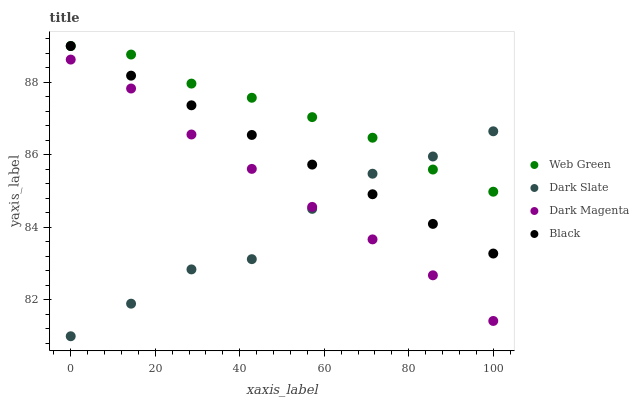Does Dark Slate have the minimum area under the curve?
Answer yes or no. Yes. Does Web Green have the maximum area under the curve?
Answer yes or no. Yes. Does Black have the minimum area under the curve?
Answer yes or no. No. Does Black have the maximum area under the curve?
Answer yes or no. No. Is Black the smoothest?
Answer yes or no. Yes. Is Dark Slate the roughest?
Answer yes or no. Yes. Is Dark Magenta the smoothest?
Answer yes or no. No. Is Dark Magenta the roughest?
Answer yes or no. No. Does Dark Slate have the lowest value?
Answer yes or no. Yes. Does Black have the lowest value?
Answer yes or no. No. Does Web Green have the highest value?
Answer yes or no. Yes. Does Dark Magenta have the highest value?
Answer yes or no. No. Is Dark Magenta less than Web Green?
Answer yes or no. Yes. Is Black greater than Dark Magenta?
Answer yes or no. Yes. Does Dark Slate intersect Web Green?
Answer yes or no. Yes. Is Dark Slate less than Web Green?
Answer yes or no. No. Is Dark Slate greater than Web Green?
Answer yes or no. No. Does Dark Magenta intersect Web Green?
Answer yes or no. No. 